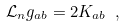Convert formula to latex. <formula><loc_0><loc_0><loc_500><loc_500>\mathcal { L } _ { n } g _ { a b } = 2 K _ { a b } \ ,</formula> 